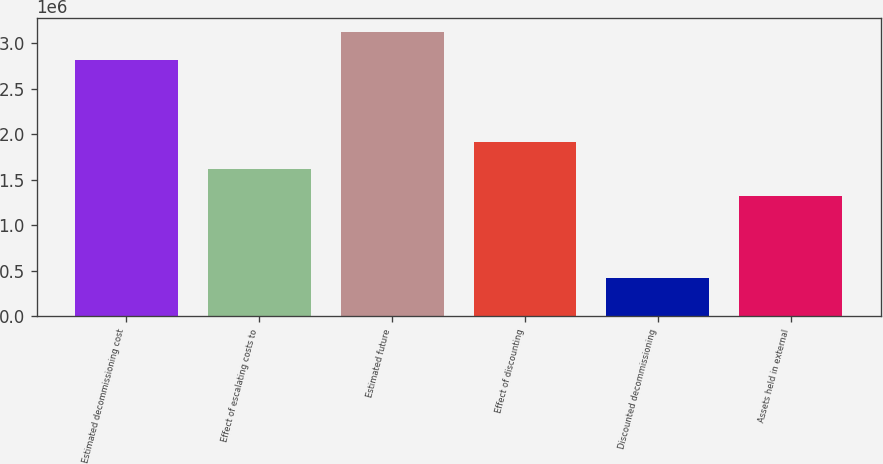<chart> <loc_0><loc_0><loc_500><loc_500><bar_chart><fcel>Estimated decommissioning cost<fcel>Effect of escalating costs to<fcel>Estimated future<fcel>Effect of discounting<fcel>Discounted decommissioning<fcel>Assets held in external<nl><fcel>2.8191e+06<fcel>1.61787e+06<fcel>3.12683e+06<fcel>1.91818e+06<fcel>424068<fcel>1.31756e+06<nl></chart> 